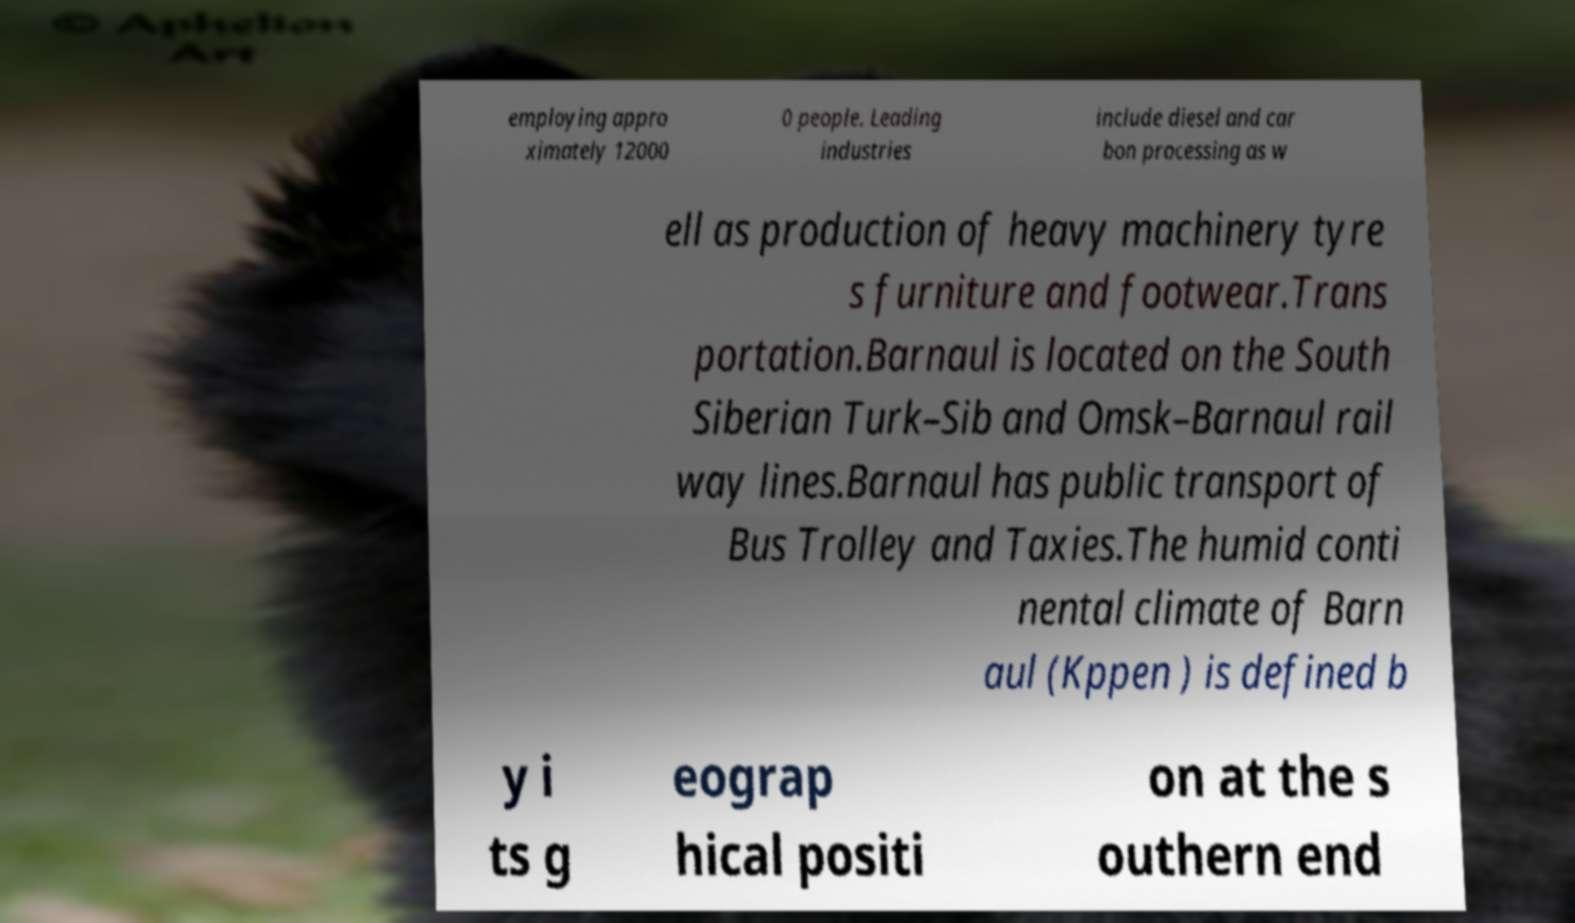Please read and relay the text visible in this image. What does it say? employing appro ximately 12000 0 people. Leading industries include diesel and car bon processing as w ell as production of heavy machinery tyre s furniture and footwear.Trans portation.Barnaul is located on the South Siberian Turk–Sib and Omsk–Barnaul rail way lines.Barnaul has public transport of Bus Trolley and Taxies.The humid conti nental climate of Barn aul (Kppen ) is defined b y i ts g eograp hical positi on at the s outhern end 